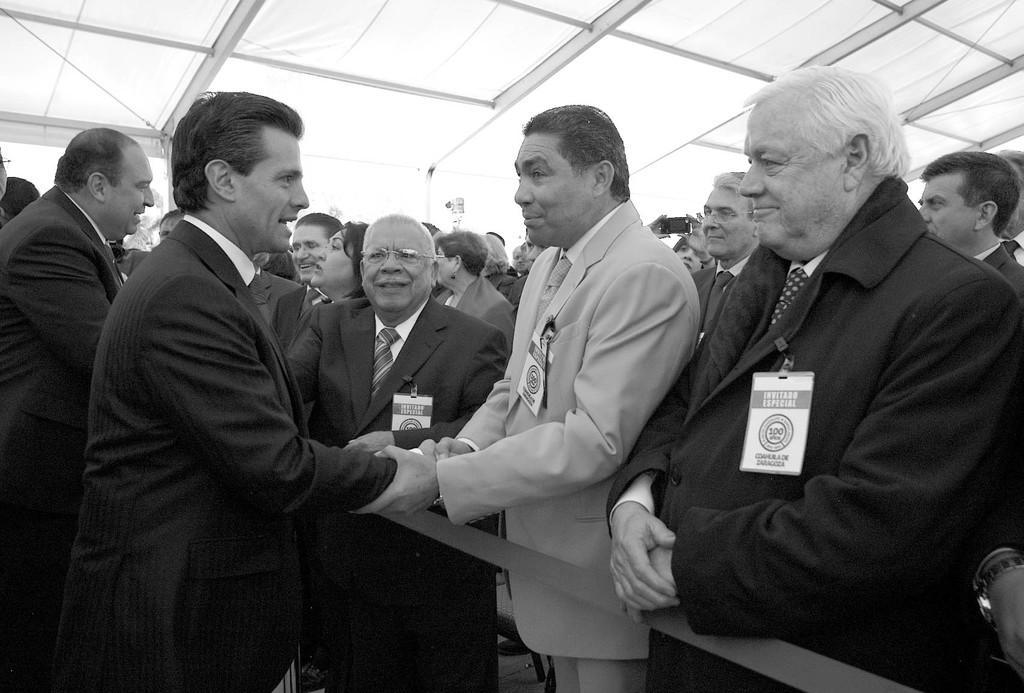Can you describe this image briefly? This is a black and white image where we can see so many people. They are wearing coats. At the top of the image, we can see the roof. At the bottom of the image, we can see a ribbon. 